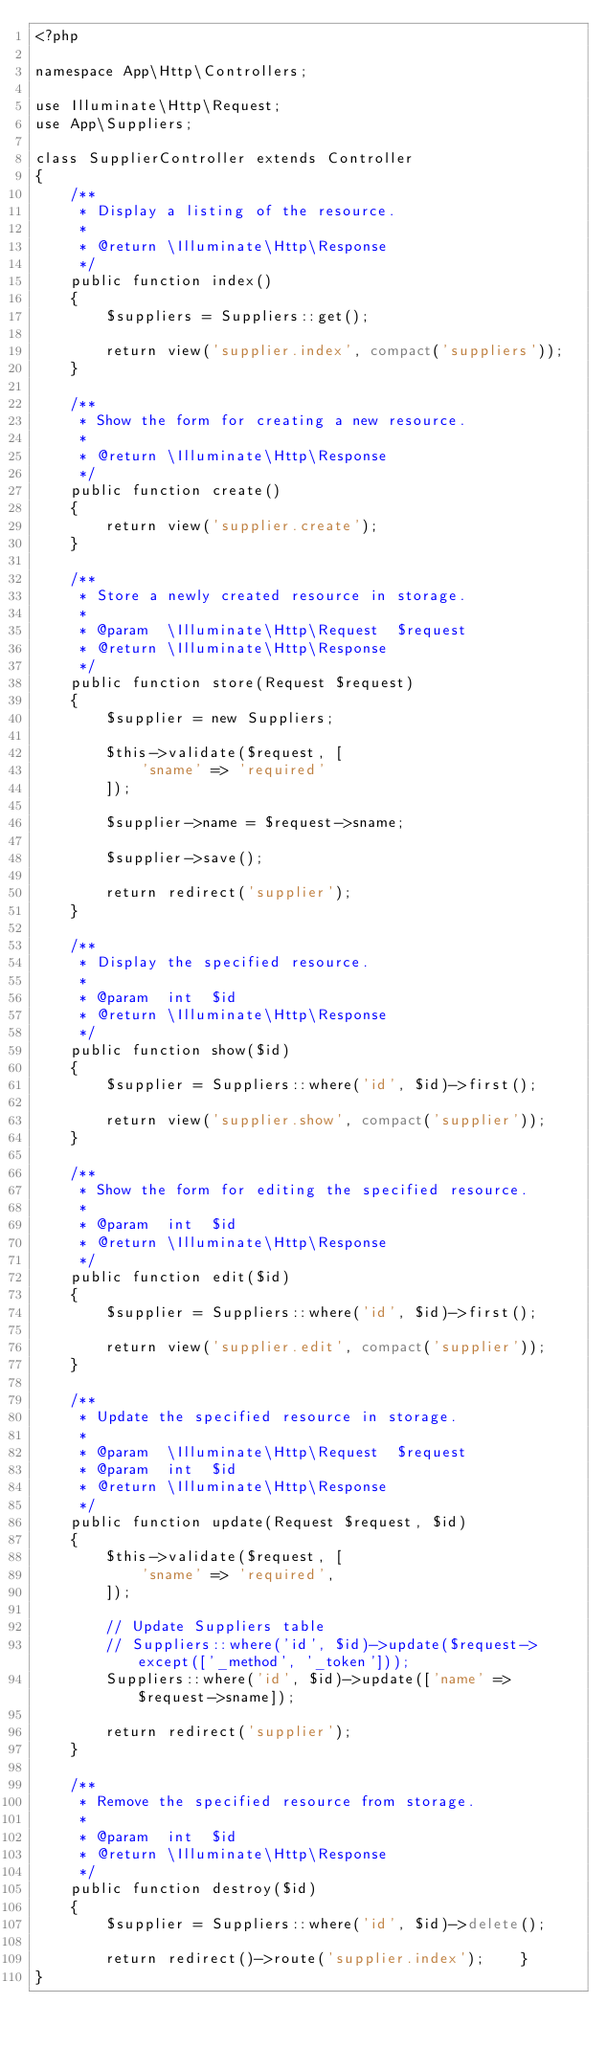<code> <loc_0><loc_0><loc_500><loc_500><_PHP_><?php

namespace App\Http\Controllers;

use Illuminate\Http\Request;
use App\Suppliers;

class SupplierController extends Controller
{
    /**
     * Display a listing of the resource.
     *
     * @return \Illuminate\Http\Response
     */
    public function index()
    {
        $suppliers = Suppliers::get();

        return view('supplier.index', compact('suppliers'));
    }

    /**
     * Show the form for creating a new resource.
     *
     * @return \Illuminate\Http\Response
     */
    public function create()
    {
        return view('supplier.create');
    }

    /**
     * Store a newly created resource in storage.
     *
     * @param  \Illuminate\Http\Request  $request
     * @return \Illuminate\Http\Response
     */
    public function store(Request $request)
    {
        $supplier = new Suppliers;

        $this->validate($request, [
            'sname' => 'required'
        ]);

        $supplier->name = $request->sname;

        $supplier->save();

        return redirect('supplier');
    }

    /**
     * Display the specified resource.
     *
     * @param  int  $id
     * @return \Illuminate\Http\Response
     */
    public function show($id)
    {
        $supplier = Suppliers::where('id', $id)->first();

        return view('supplier.show', compact('supplier'));
    }

    /**
     * Show the form for editing the specified resource.
     *
     * @param  int  $id
     * @return \Illuminate\Http\Response
     */
    public function edit($id)
    {
        $supplier = Suppliers::where('id', $id)->first();

        return view('supplier.edit', compact('supplier'));
    }

    /**
     * Update the specified resource in storage.
     *
     * @param  \Illuminate\Http\Request  $request
     * @param  int  $id
     * @return \Illuminate\Http\Response
     */
    public function update(Request $request, $id)
    {
        $this->validate($request, [
            'sname' => 'required',
        ]);

        // Update Suppliers table
        // Suppliers::where('id', $id)->update($request->except(['_method', '_token']));
        Suppliers::where('id', $id)->update(['name' => $request->sname]);

        return redirect('supplier');
    }

    /**
     * Remove the specified resource from storage.
     *
     * @param  int  $id
     * @return \Illuminate\Http\Response
     */
    public function destroy($id)
    {
        $supplier = Suppliers::where('id', $id)->delete();

        return redirect()->route('supplier.index');    }
}
</code> 